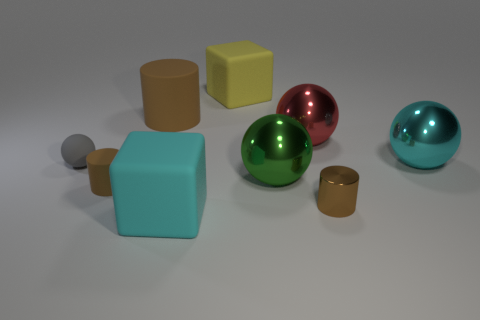What can you infer about the lighting in the scene? The lighting in the scene is soft and diffuse, casting gentle shadows beneath the objects. This suggests an environment with ambient light, such as what might be found in a studio setting with multiple light sources or a softbox to eliminate harsh shadows. 